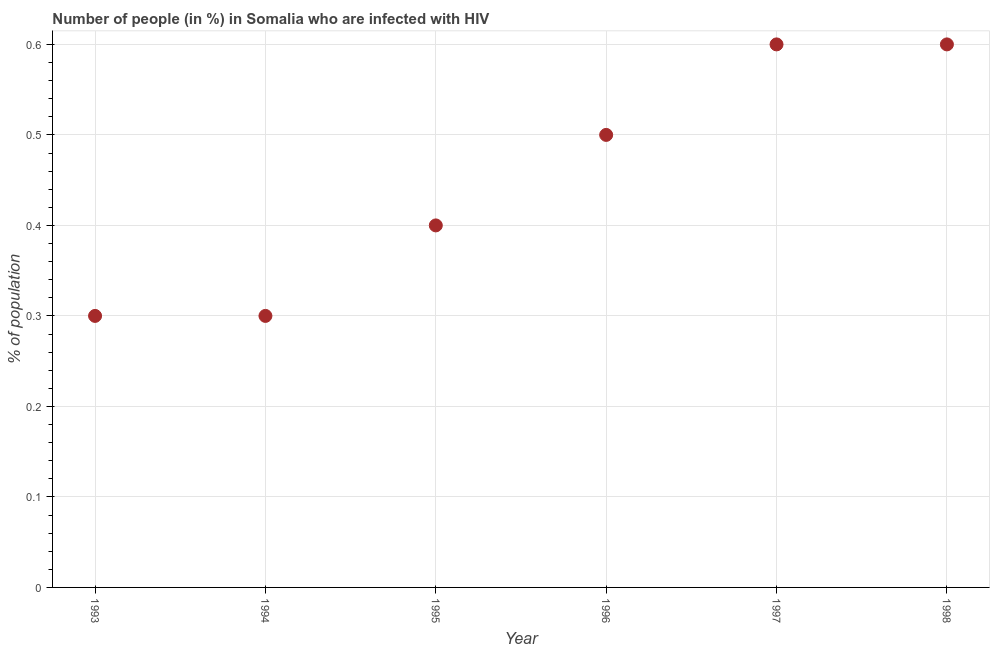Across all years, what is the minimum number of people infected with hiv?
Your answer should be compact. 0.3. In which year was the number of people infected with hiv maximum?
Ensure brevity in your answer.  1997. What is the sum of the number of people infected with hiv?
Keep it short and to the point. 2.7. What is the difference between the number of people infected with hiv in 1993 and 1996?
Offer a terse response. -0.2. What is the average number of people infected with hiv per year?
Your answer should be very brief. 0.45. What is the median number of people infected with hiv?
Give a very brief answer. 0.45. In how many years, is the number of people infected with hiv greater than 0.58 %?
Your answer should be very brief. 2. Do a majority of the years between 1994 and 1993 (inclusive) have number of people infected with hiv greater than 0.58 %?
Provide a short and direct response. No. What is the ratio of the number of people infected with hiv in 1994 to that in 1997?
Offer a very short reply. 0.5. What is the difference between the highest and the second highest number of people infected with hiv?
Provide a succinct answer. 0. What is the difference between the highest and the lowest number of people infected with hiv?
Make the answer very short. 0.3. In how many years, is the number of people infected with hiv greater than the average number of people infected with hiv taken over all years?
Offer a very short reply. 3. Does the number of people infected with hiv monotonically increase over the years?
Your answer should be very brief. No. How many dotlines are there?
Keep it short and to the point. 1. How many years are there in the graph?
Provide a succinct answer. 6. Are the values on the major ticks of Y-axis written in scientific E-notation?
Offer a very short reply. No. Does the graph contain grids?
Provide a succinct answer. Yes. What is the title of the graph?
Offer a very short reply. Number of people (in %) in Somalia who are infected with HIV. What is the label or title of the X-axis?
Offer a terse response. Year. What is the label or title of the Y-axis?
Offer a terse response. % of population. What is the % of population in 1993?
Ensure brevity in your answer.  0.3. What is the % of population in 1997?
Offer a very short reply. 0.6. What is the % of population in 1998?
Your answer should be very brief. 0.6. What is the difference between the % of population in 1993 and 1994?
Offer a very short reply. 0. What is the difference between the % of population in 1993 and 1998?
Your answer should be compact. -0.3. What is the difference between the % of population in 1994 and 1996?
Provide a succinct answer. -0.2. What is the difference between the % of population in 1994 and 1997?
Ensure brevity in your answer.  -0.3. What is the difference between the % of population in 1995 and 1998?
Provide a short and direct response. -0.2. What is the difference between the % of population in 1996 and 1997?
Your answer should be very brief. -0.1. What is the difference between the % of population in 1996 and 1998?
Keep it short and to the point. -0.1. What is the difference between the % of population in 1997 and 1998?
Offer a very short reply. 0. What is the ratio of the % of population in 1993 to that in 1995?
Give a very brief answer. 0.75. What is the ratio of the % of population in 1993 to that in 1998?
Ensure brevity in your answer.  0.5. What is the ratio of the % of population in 1994 to that in 1996?
Your answer should be compact. 0.6. What is the ratio of the % of population in 1994 to that in 1997?
Your response must be concise. 0.5. What is the ratio of the % of population in 1994 to that in 1998?
Keep it short and to the point. 0.5. What is the ratio of the % of population in 1995 to that in 1997?
Give a very brief answer. 0.67. What is the ratio of the % of population in 1995 to that in 1998?
Keep it short and to the point. 0.67. What is the ratio of the % of population in 1996 to that in 1997?
Make the answer very short. 0.83. What is the ratio of the % of population in 1996 to that in 1998?
Your answer should be very brief. 0.83. What is the ratio of the % of population in 1997 to that in 1998?
Provide a succinct answer. 1. 